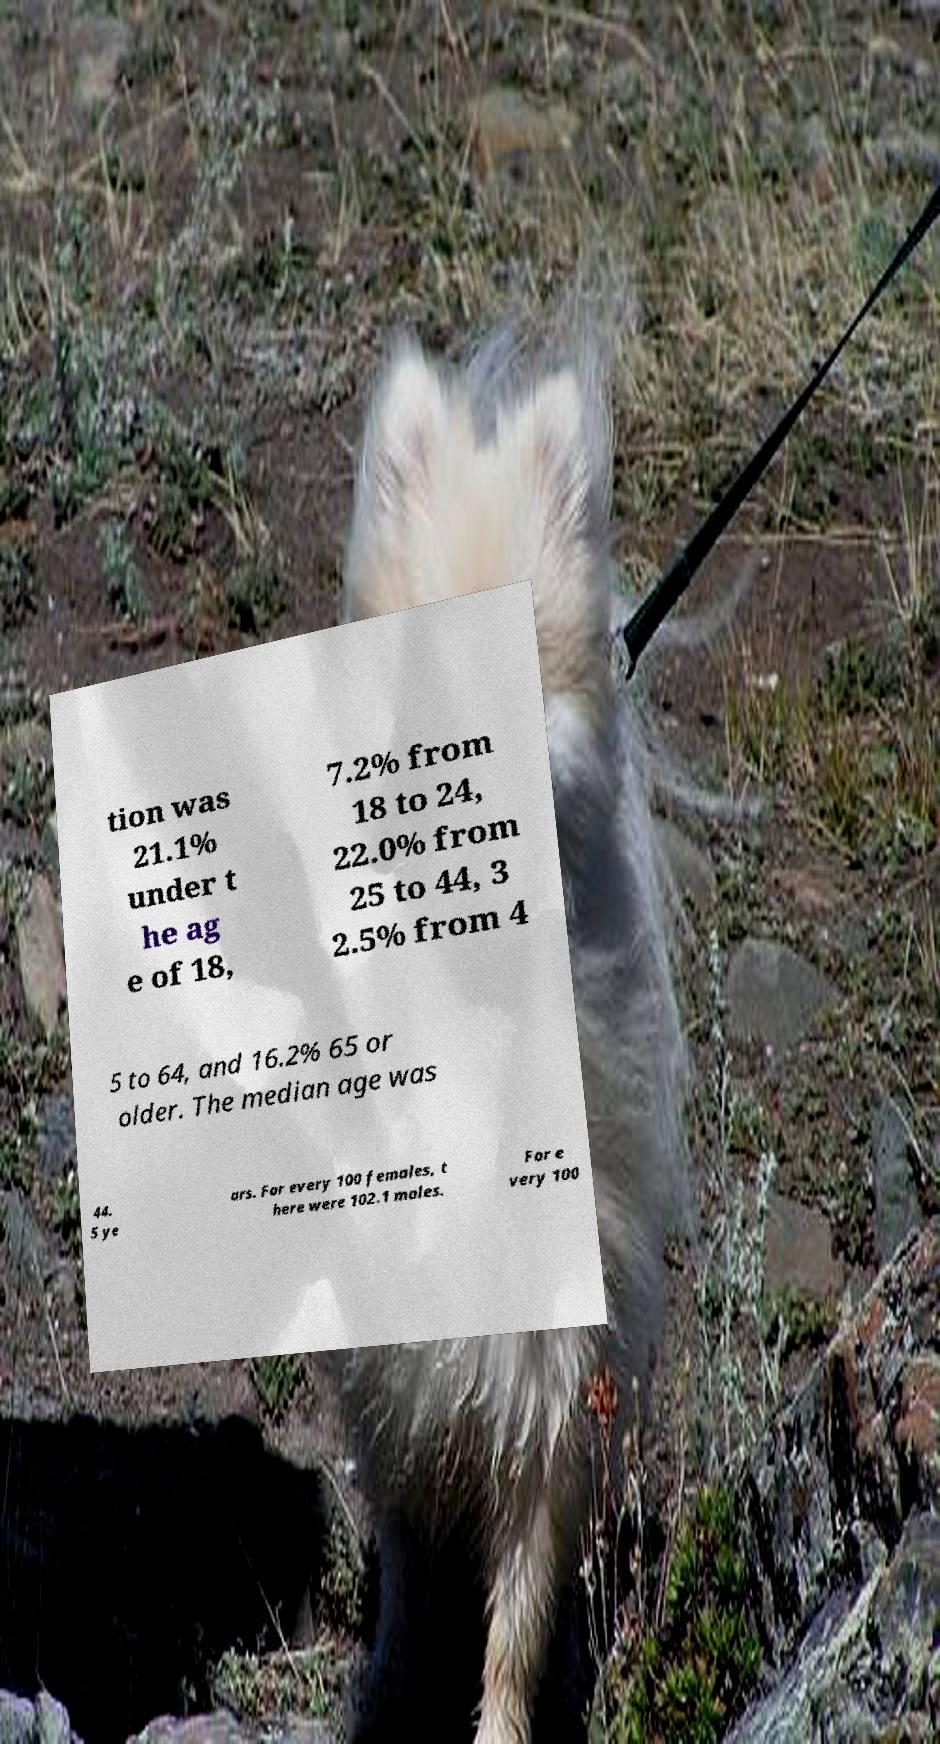Please identify and transcribe the text found in this image. tion was 21.1% under t he ag e of 18, 7.2% from 18 to 24, 22.0% from 25 to 44, 3 2.5% from 4 5 to 64, and 16.2% 65 or older. The median age was 44. 5 ye ars. For every 100 females, t here were 102.1 males. For e very 100 